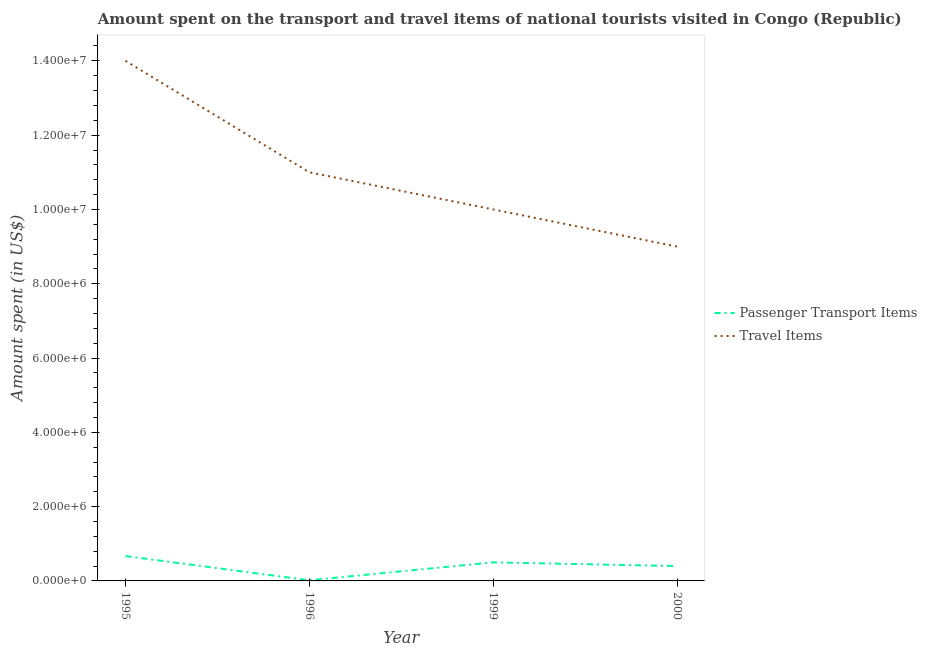What is the amount spent in travel items in 2000?
Provide a short and direct response. 9.00e+06. Across all years, what is the maximum amount spent on passenger transport items?
Your response must be concise. 6.69e+05. Across all years, what is the minimum amount spent on passenger transport items?
Your response must be concise. 1.76e+04. In which year was the amount spent in travel items minimum?
Ensure brevity in your answer.  2000. What is the total amount spent in travel items in the graph?
Provide a short and direct response. 4.40e+07. What is the difference between the amount spent on passenger transport items in 1995 and that in 1999?
Offer a terse response. 1.69e+05. What is the difference between the amount spent in travel items in 2000 and the amount spent on passenger transport items in 1996?
Offer a terse response. 8.98e+06. What is the average amount spent on passenger transport items per year?
Your answer should be compact. 3.97e+05. In the year 1999, what is the difference between the amount spent on passenger transport items and amount spent in travel items?
Provide a short and direct response. -9.50e+06. What is the ratio of the amount spent in travel items in 1995 to that in 2000?
Offer a very short reply. 1.56. Is the amount spent on passenger transport items in 1996 less than that in 1999?
Offer a terse response. Yes. What is the difference between the highest and the lowest amount spent on passenger transport items?
Offer a terse response. 6.52e+05. Is the sum of the amount spent on passenger transport items in 1995 and 1999 greater than the maximum amount spent in travel items across all years?
Keep it short and to the point. No. Is the amount spent on passenger transport items strictly greater than the amount spent in travel items over the years?
Ensure brevity in your answer.  No. Is the amount spent in travel items strictly less than the amount spent on passenger transport items over the years?
Make the answer very short. No. How many lines are there?
Ensure brevity in your answer.  2. How many years are there in the graph?
Ensure brevity in your answer.  4. What is the difference between two consecutive major ticks on the Y-axis?
Offer a very short reply. 2.00e+06. Does the graph contain any zero values?
Your answer should be compact. No. Where does the legend appear in the graph?
Ensure brevity in your answer.  Center right. How are the legend labels stacked?
Offer a very short reply. Vertical. What is the title of the graph?
Provide a succinct answer. Amount spent on the transport and travel items of national tourists visited in Congo (Republic). What is the label or title of the X-axis?
Make the answer very short. Year. What is the label or title of the Y-axis?
Offer a terse response. Amount spent (in US$). What is the Amount spent (in US$) in Passenger Transport Items in 1995?
Offer a very short reply. 6.69e+05. What is the Amount spent (in US$) in Travel Items in 1995?
Keep it short and to the point. 1.40e+07. What is the Amount spent (in US$) in Passenger Transport Items in 1996?
Provide a succinct answer. 1.76e+04. What is the Amount spent (in US$) of Travel Items in 1996?
Keep it short and to the point. 1.10e+07. What is the Amount spent (in US$) of Travel Items in 1999?
Ensure brevity in your answer.  1.00e+07. What is the Amount spent (in US$) of Travel Items in 2000?
Your response must be concise. 9.00e+06. Across all years, what is the maximum Amount spent (in US$) of Passenger Transport Items?
Your answer should be compact. 6.69e+05. Across all years, what is the maximum Amount spent (in US$) of Travel Items?
Keep it short and to the point. 1.40e+07. Across all years, what is the minimum Amount spent (in US$) in Passenger Transport Items?
Make the answer very short. 1.76e+04. Across all years, what is the minimum Amount spent (in US$) of Travel Items?
Give a very brief answer. 9.00e+06. What is the total Amount spent (in US$) in Passenger Transport Items in the graph?
Keep it short and to the point. 1.59e+06. What is the total Amount spent (in US$) in Travel Items in the graph?
Offer a terse response. 4.40e+07. What is the difference between the Amount spent (in US$) of Passenger Transport Items in 1995 and that in 1996?
Your answer should be very brief. 6.52e+05. What is the difference between the Amount spent (in US$) in Passenger Transport Items in 1995 and that in 1999?
Your answer should be very brief. 1.69e+05. What is the difference between the Amount spent (in US$) in Travel Items in 1995 and that in 1999?
Your response must be concise. 4.00e+06. What is the difference between the Amount spent (in US$) of Passenger Transport Items in 1995 and that in 2000?
Your answer should be very brief. 2.69e+05. What is the difference between the Amount spent (in US$) of Passenger Transport Items in 1996 and that in 1999?
Ensure brevity in your answer.  -4.82e+05. What is the difference between the Amount spent (in US$) in Travel Items in 1996 and that in 1999?
Keep it short and to the point. 1.00e+06. What is the difference between the Amount spent (in US$) of Passenger Transport Items in 1996 and that in 2000?
Your answer should be compact. -3.82e+05. What is the difference between the Amount spent (in US$) of Travel Items in 1996 and that in 2000?
Ensure brevity in your answer.  2.00e+06. What is the difference between the Amount spent (in US$) of Passenger Transport Items in 1999 and that in 2000?
Provide a succinct answer. 1.00e+05. What is the difference between the Amount spent (in US$) in Travel Items in 1999 and that in 2000?
Your response must be concise. 1.00e+06. What is the difference between the Amount spent (in US$) in Passenger Transport Items in 1995 and the Amount spent (in US$) in Travel Items in 1996?
Offer a terse response. -1.03e+07. What is the difference between the Amount spent (in US$) in Passenger Transport Items in 1995 and the Amount spent (in US$) in Travel Items in 1999?
Your answer should be very brief. -9.33e+06. What is the difference between the Amount spent (in US$) of Passenger Transport Items in 1995 and the Amount spent (in US$) of Travel Items in 2000?
Your answer should be compact. -8.33e+06. What is the difference between the Amount spent (in US$) in Passenger Transport Items in 1996 and the Amount spent (in US$) in Travel Items in 1999?
Provide a short and direct response. -9.98e+06. What is the difference between the Amount spent (in US$) in Passenger Transport Items in 1996 and the Amount spent (in US$) in Travel Items in 2000?
Your answer should be very brief. -8.98e+06. What is the difference between the Amount spent (in US$) in Passenger Transport Items in 1999 and the Amount spent (in US$) in Travel Items in 2000?
Provide a short and direct response. -8.50e+06. What is the average Amount spent (in US$) in Passenger Transport Items per year?
Keep it short and to the point. 3.97e+05. What is the average Amount spent (in US$) in Travel Items per year?
Offer a terse response. 1.10e+07. In the year 1995, what is the difference between the Amount spent (in US$) in Passenger Transport Items and Amount spent (in US$) in Travel Items?
Provide a succinct answer. -1.33e+07. In the year 1996, what is the difference between the Amount spent (in US$) in Passenger Transport Items and Amount spent (in US$) in Travel Items?
Offer a terse response. -1.10e+07. In the year 1999, what is the difference between the Amount spent (in US$) in Passenger Transport Items and Amount spent (in US$) in Travel Items?
Your answer should be very brief. -9.50e+06. In the year 2000, what is the difference between the Amount spent (in US$) in Passenger Transport Items and Amount spent (in US$) in Travel Items?
Offer a very short reply. -8.60e+06. What is the ratio of the Amount spent (in US$) in Passenger Transport Items in 1995 to that in 1996?
Your answer should be compact. 38.03. What is the ratio of the Amount spent (in US$) in Travel Items in 1995 to that in 1996?
Keep it short and to the point. 1.27. What is the ratio of the Amount spent (in US$) of Passenger Transport Items in 1995 to that in 1999?
Offer a very short reply. 1.34. What is the ratio of the Amount spent (in US$) of Travel Items in 1995 to that in 1999?
Your answer should be very brief. 1.4. What is the ratio of the Amount spent (in US$) of Passenger Transport Items in 1995 to that in 2000?
Provide a short and direct response. 1.67. What is the ratio of the Amount spent (in US$) of Travel Items in 1995 to that in 2000?
Ensure brevity in your answer.  1.56. What is the ratio of the Amount spent (in US$) in Passenger Transport Items in 1996 to that in 1999?
Your answer should be compact. 0.04. What is the ratio of the Amount spent (in US$) in Passenger Transport Items in 1996 to that in 2000?
Your answer should be compact. 0.04. What is the ratio of the Amount spent (in US$) in Travel Items in 1996 to that in 2000?
Provide a succinct answer. 1.22. What is the difference between the highest and the second highest Amount spent (in US$) of Passenger Transport Items?
Make the answer very short. 1.69e+05. What is the difference between the highest and the second highest Amount spent (in US$) of Travel Items?
Make the answer very short. 3.00e+06. What is the difference between the highest and the lowest Amount spent (in US$) in Passenger Transport Items?
Provide a succinct answer. 6.52e+05. 